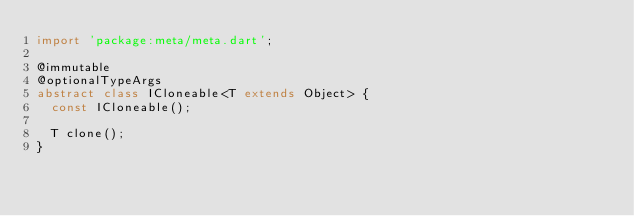<code> <loc_0><loc_0><loc_500><loc_500><_Dart_>import 'package:meta/meta.dart';

@immutable
@optionalTypeArgs
abstract class ICloneable<T extends Object> {
  const ICloneable();

  T clone();
}
</code> 